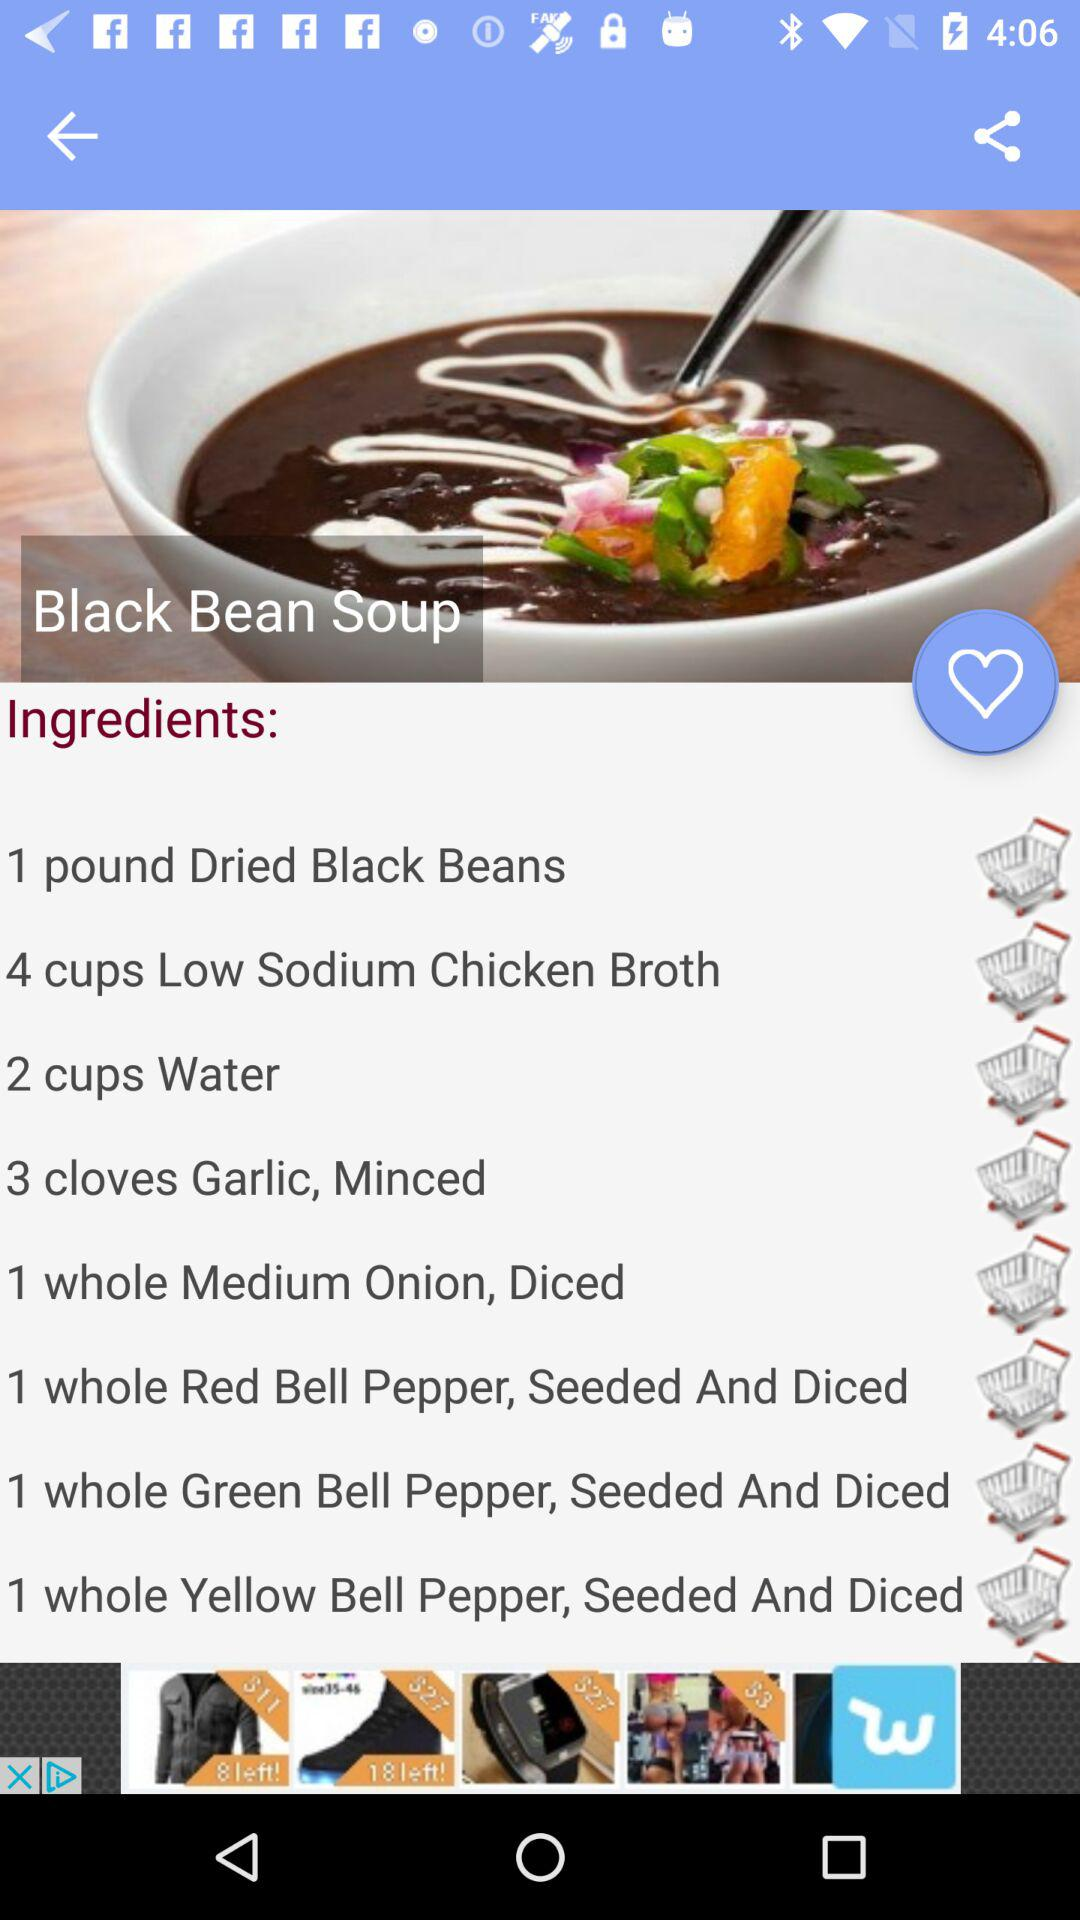What ingredients are shown for the "Black Bean Soup" recipe? The ingredients are "1 pound Dried Black Beans", "4 cups Low Sodium Chicken Broth", "2 cups Water", "3 cloves Garlic, Minced", "1 whole Medium Onion, Diced", "1 whole Red Bell Pepper, Seeded And Diced", "1 whole Green Bell Pepper, Seeded And Diced" and "1 whole Yellow Bell Pepper, Seeded And Diced". 